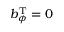Convert formula to latex. <formula><loc_0><loc_0><loc_500><loc_500>b _ { \phi } ^ { T } = 0</formula> 